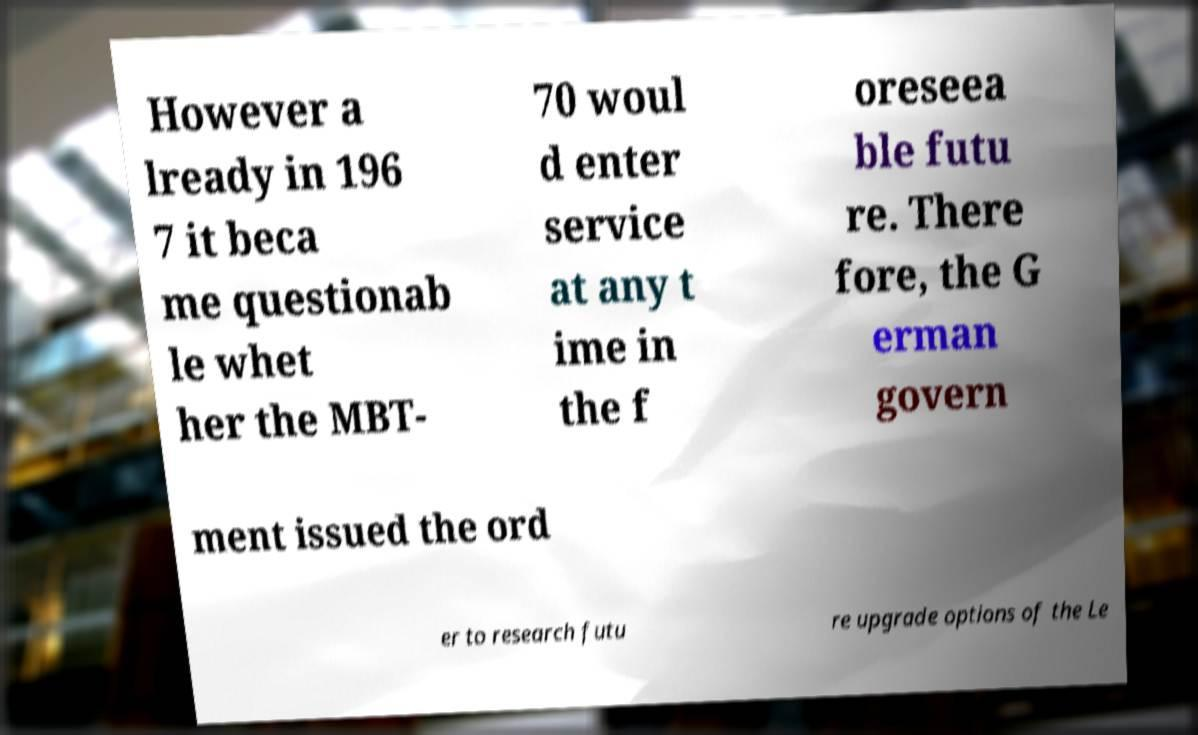Can you accurately transcribe the text from the provided image for me? However a lready in 196 7 it beca me questionab le whet her the MBT- 70 woul d enter service at any t ime in the f oreseea ble futu re. There fore, the G erman govern ment issued the ord er to research futu re upgrade options of the Le 